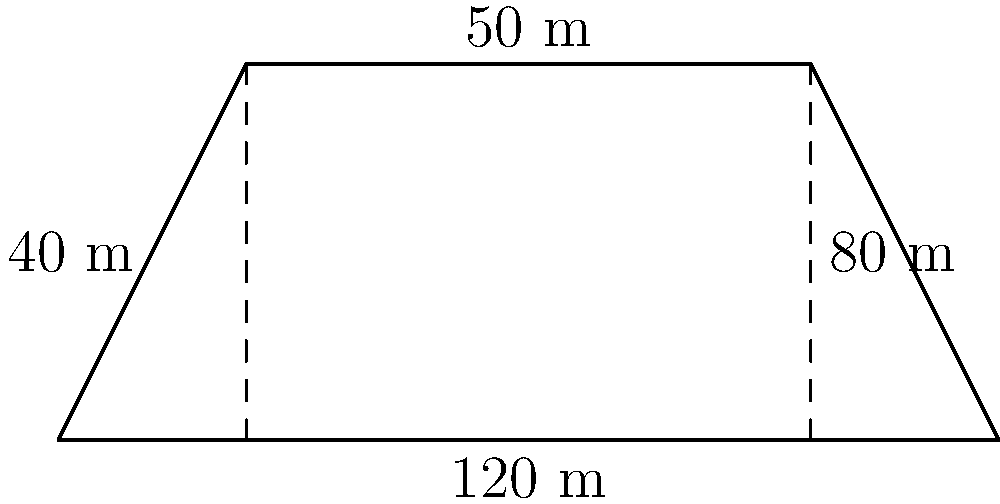A hydroelectric dam reservoir has a trapezoidal cross-section as shown in the figure. The bottom width of the reservoir is 120 m, the top width is 50 m, and the depths at the left and right sides are 40 m and 80 m, respectively. Calculate the cross-sectional area of the reservoir in square meters. To calculate the cross-sectional area of the trapezoidal reservoir, we can use the formula for the area of a trapezoid:

$$ A = \frac{1}{2}(b_1 + b_2)h $$

Where:
$A$ = area
$b_1$ = bottom base (width)
$b_2$ = top base (width)
$h$ = height (average depth)

Given:
$b_1 = 120$ m
$b_2 = 50$ m
Left depth = 40 m
Right depth = 80 m

Step 1: Calculate the average depth (height)
$$ h = \frac{40 \text{ m} + 80 \text{ m}}{2} = 60 \text{ m} $$

Step 2: Apply the trapezoid area formula
$$ A = \frac{1}{2}(120 \text{ m} + 50 \text{ m}) \times 60 \text{ m} $$
$$ A = \frac{1}{2}(170 \text{ m}) \times 60 \text{ m} $$
$$ A = 85 \text{ m} \times 60 \text{ m} $$
$$ A = 5,100 \text{ m}^2 $$

Therefore, the cross-sectional area of the reservoir is 5,100 square meters.
Answer: 5,100 m² 